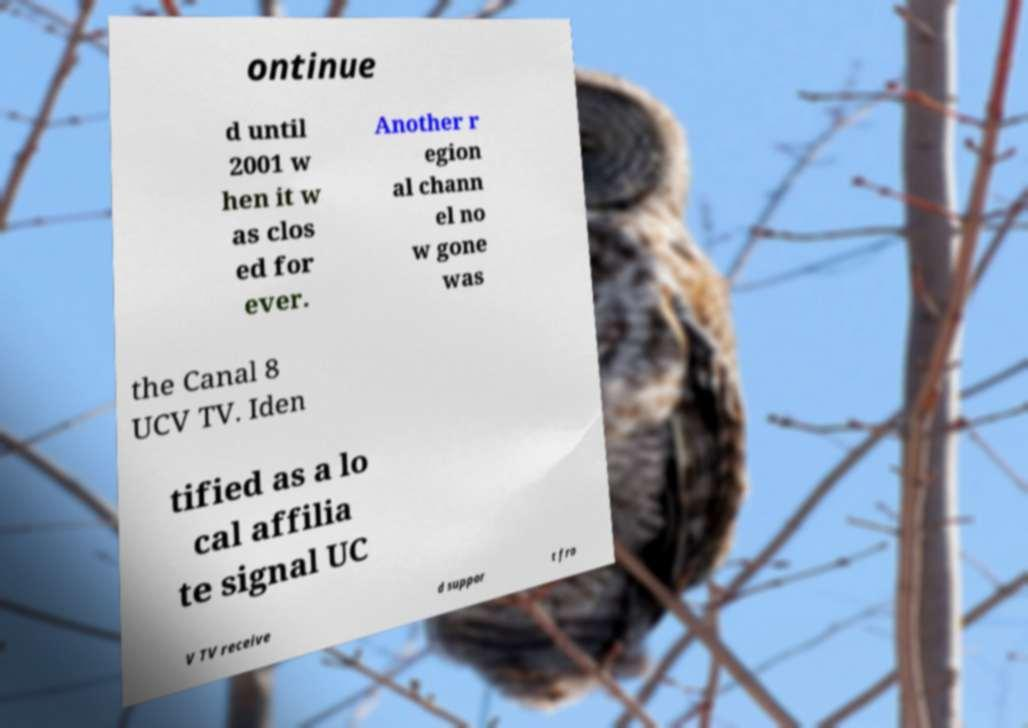There's text embedded in this image that I need extracted. Can you transcribe it verbatim? ontinue d until 2001 w hen it w as clos ed for ever. Another r egion al chann el no w gone was the Canal 8 UCV TV. Iden tified as a lo cal affilia te signal UC V TV receive d suppor t fro 